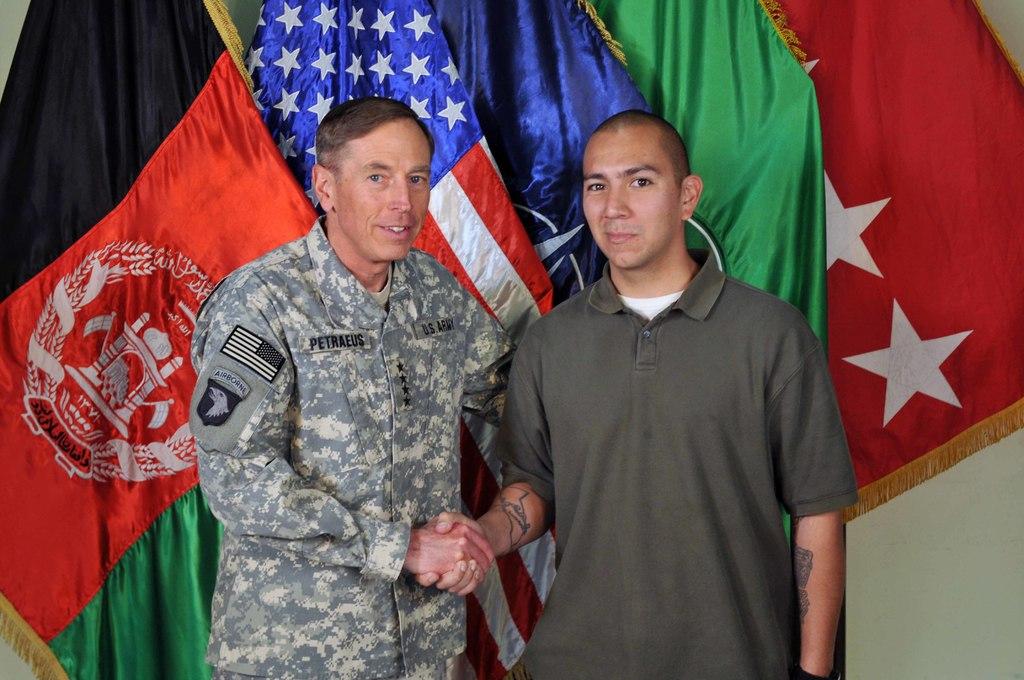What division patch is on the unifrom?
Provide a short and direct response. Airborne. 